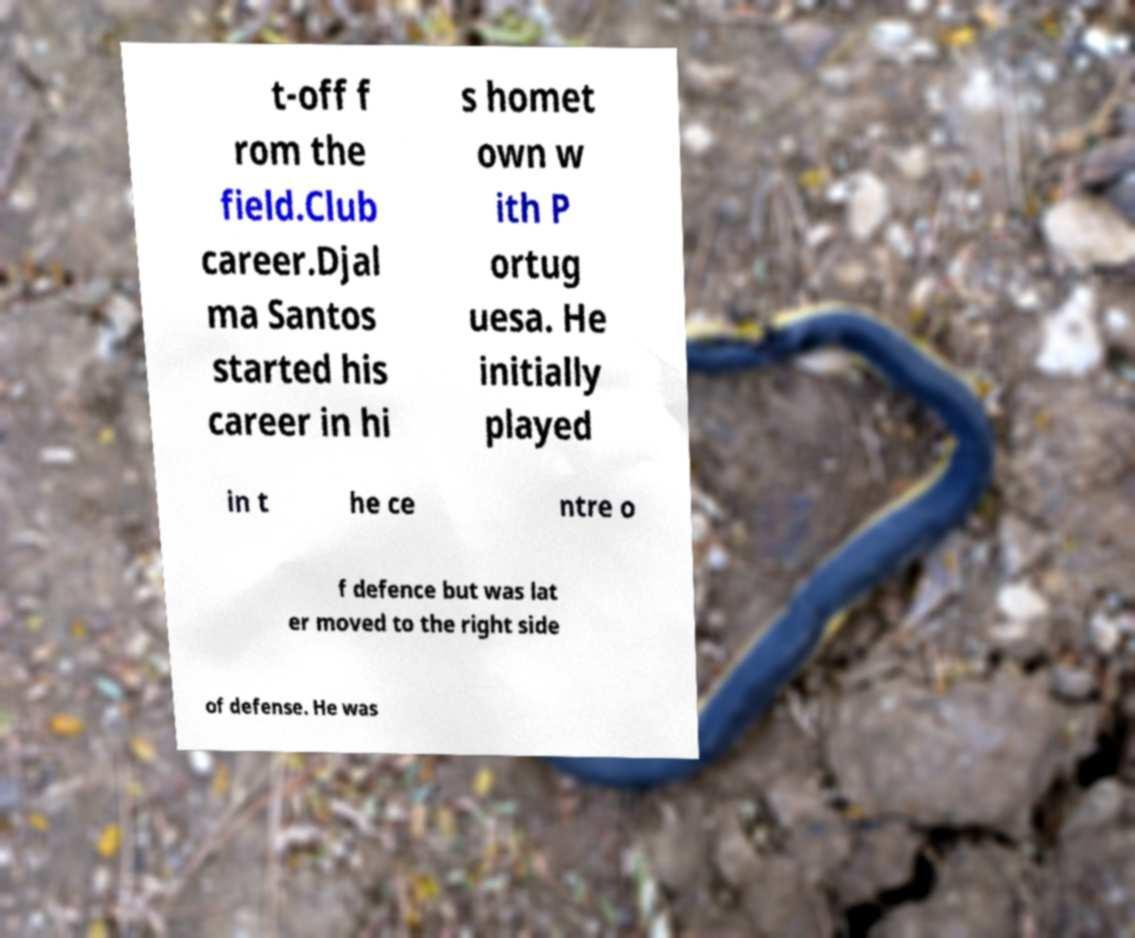For documentation purposes, I need the text within this image transcribed. Could you provide that? t-off f rom the field.Club career.Djal ma Santos started his career in hi s homet own w ith P ortug uesa. He initially played in t he ce ntre o f defence but was lat er moved to the right side of defense. He was 